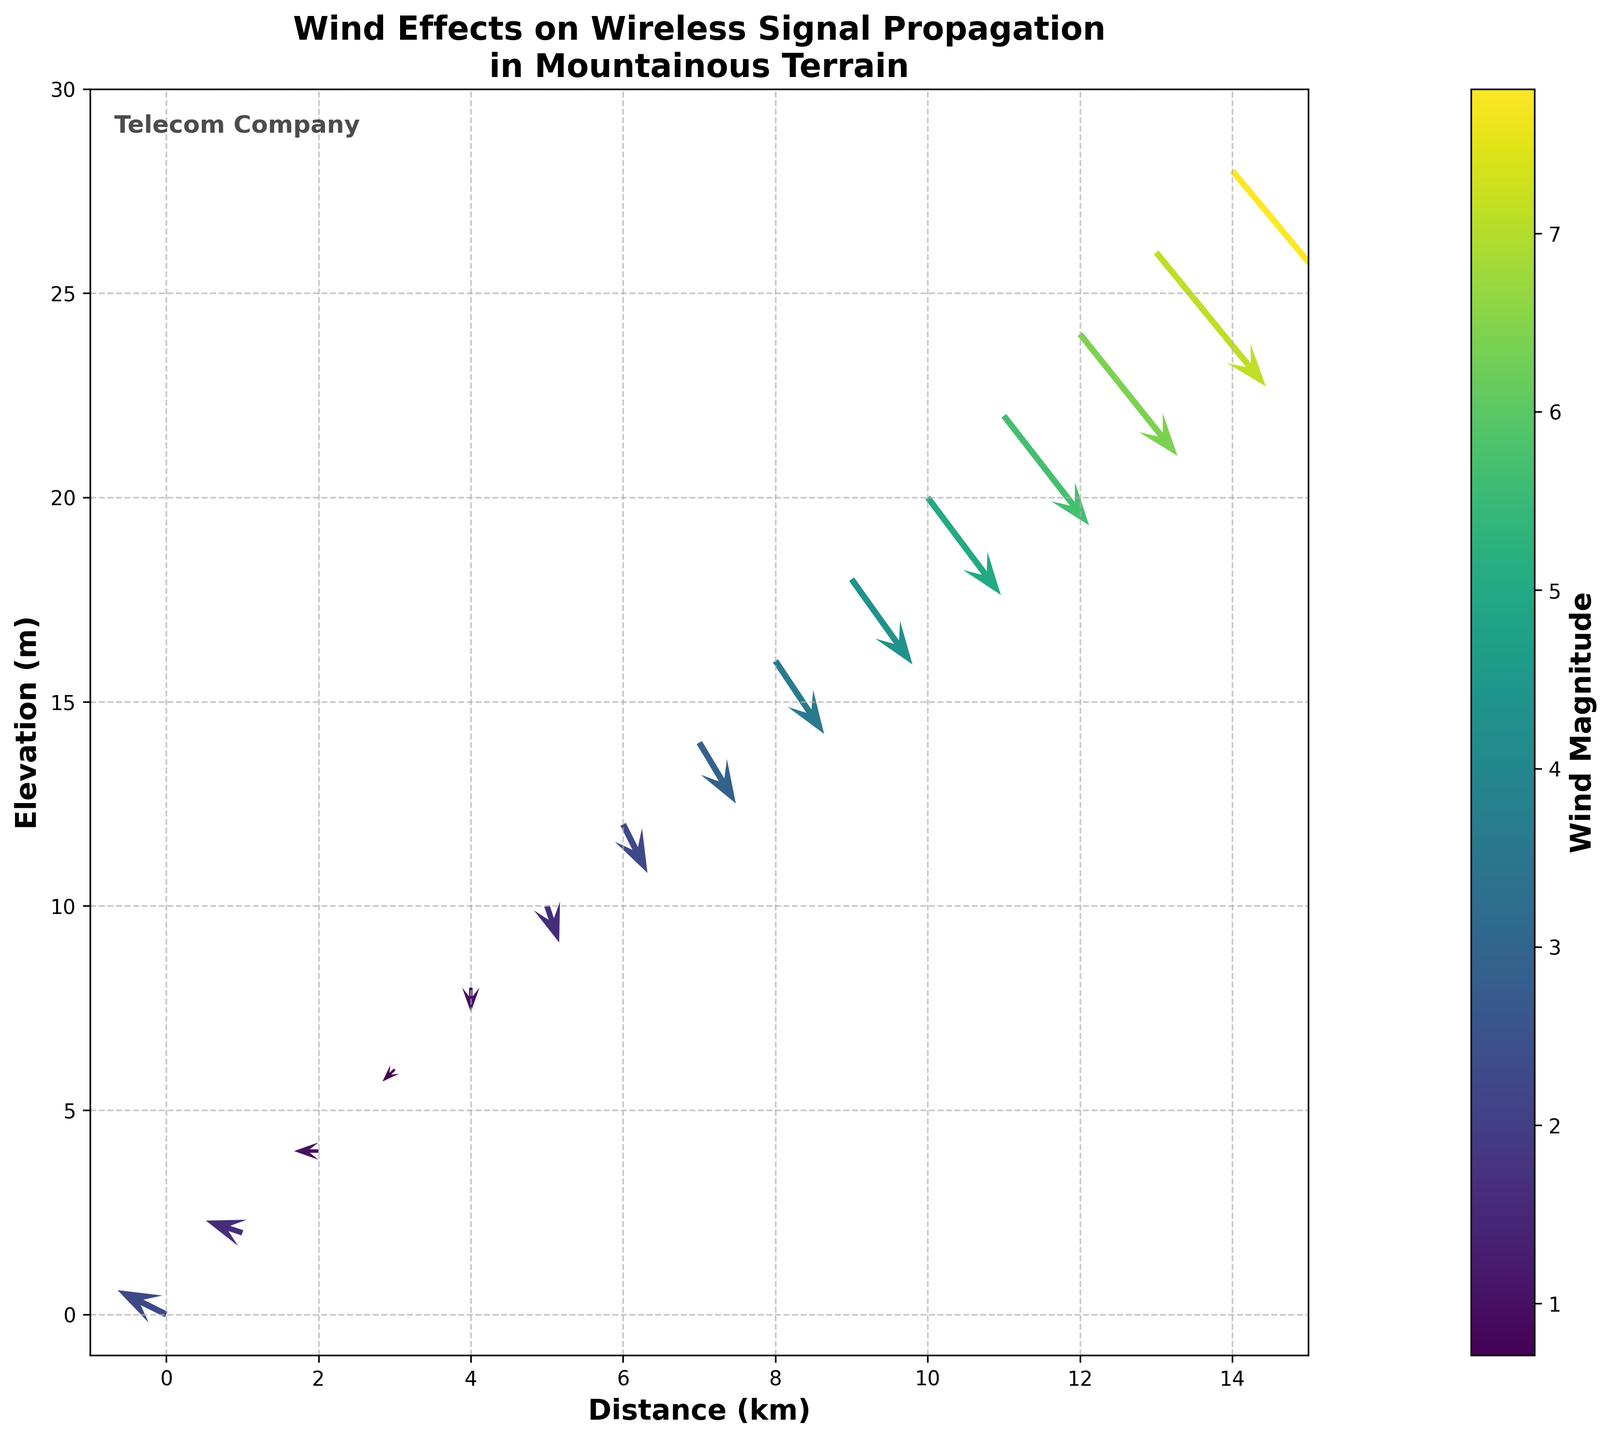What is the title of the figure? The title of the figure is centered at the top of the plot and it clearly describes what the figure is about.
Answer: Wind Effects on Wireless Signal Propagation in Mountainous Terrain What are the units used on the x-axis and y-axis? The x-axis is labeled as 'Distance (km)' indicating that the distance is measured in kilometers, and the y-axis is labeled as 'Elevation (m)' indicating that the elevation is measured in meters.
Answer: x-axis uses kilometers, y-axis uses meters How many arrows are plotted in the figure? Each row in the given data corresponds to a plotted arrow. Since there are 15 rows of data, there are 15 arrows plotted in the figure.
Answer: 15 At which location does the wind have the highest magnitude? The magnitude of the wind is given by the color of the arrows and the colorbar on the right indicates the magnitude values. The darkest color represents the highest magnitude, which occurs at the point (14, 28).
Answer: (14, 28) What is the direction of the wind vector at (4, 8)? To determine the direction of the wind vector at (4, 8), we look at the (u, v) values. Here, u=0 and v=-1, meaning the wind is blowing downwards (negative y direction).
Answer: Downwards Compare the magnitude of the wind at (0, 0) and (10, 20). Which one is higher? By looking at the color of the arrows at these coordinates and comparing them to the colorbar, we see that the arrow at (10, 20) is darker, indicating a higher magnitude. Specifically, the magnitude at (0, 0) is 2.24 and at (10, 20) is 5.00.
Answer: (10, 20) What is the average wind magnitude for the first five data points? The magnitudes for the first five data points are 2.24, 1.58, 1.00, 0.71, and 1.00. The average magnitude is calculated as (2.24 + 1.58 + 1.00 + 0.71 + 1.00) / 5 = 1.306.
Answer: 1.306 How does the wind magnitude generally change as you move up in elevation? Observing the overall color gradient from the bottom to the top of the plot, it is seen that the color of the arrows becomes darker as the elevation increases, indicating that the magnitude of the wind generally increases with elevation.
Answer: Increases What is the range of wind magnitudes shown in the figure? The colorbar on the right side indicates the range of the wind magnitudes from the lowest to the highest values. These values range from 0.71 to 7.81.
Answer: 0.71 to 7.81 Is the wind predominantly blowing uphill or downhill? By looking at the directions of most arrows in the plot, it is clear that the wind vectors predominantly point downhill from higher to lower elevations.
Answer: Downhill 